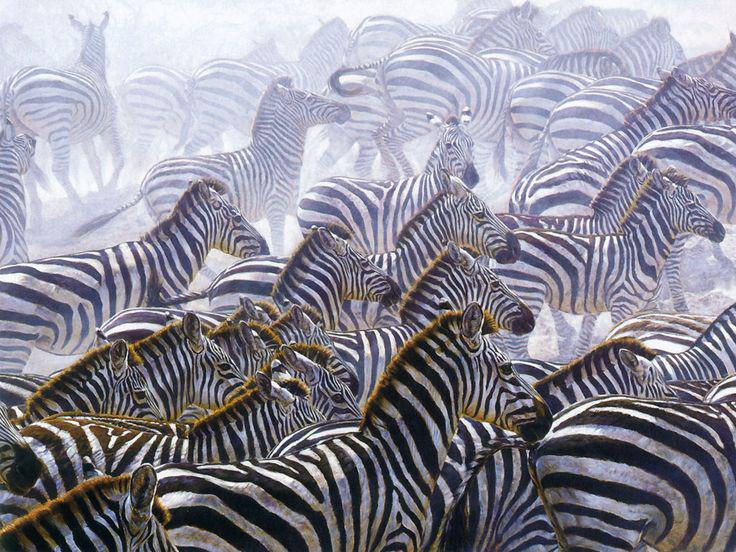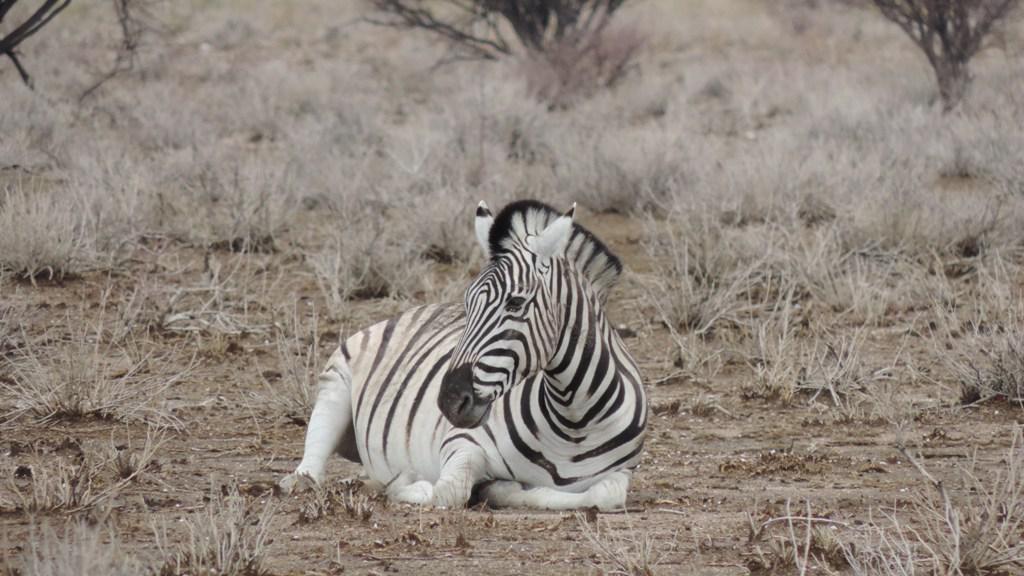The first image is the image on the left, the second image is the image on the right. For the images shown, is this caption "One image shows multiple zebras standing in water up to their knees, and the other image shows multiple zebras standing on dry ground." true? Answer yes or no. No. The first image is the image on the left, the second image is the image on the right. Analyze the images presented: Is the assertion "One image shows zebras in water and the other image shows zebras on grassland." valid? Answer yes or no. No. 